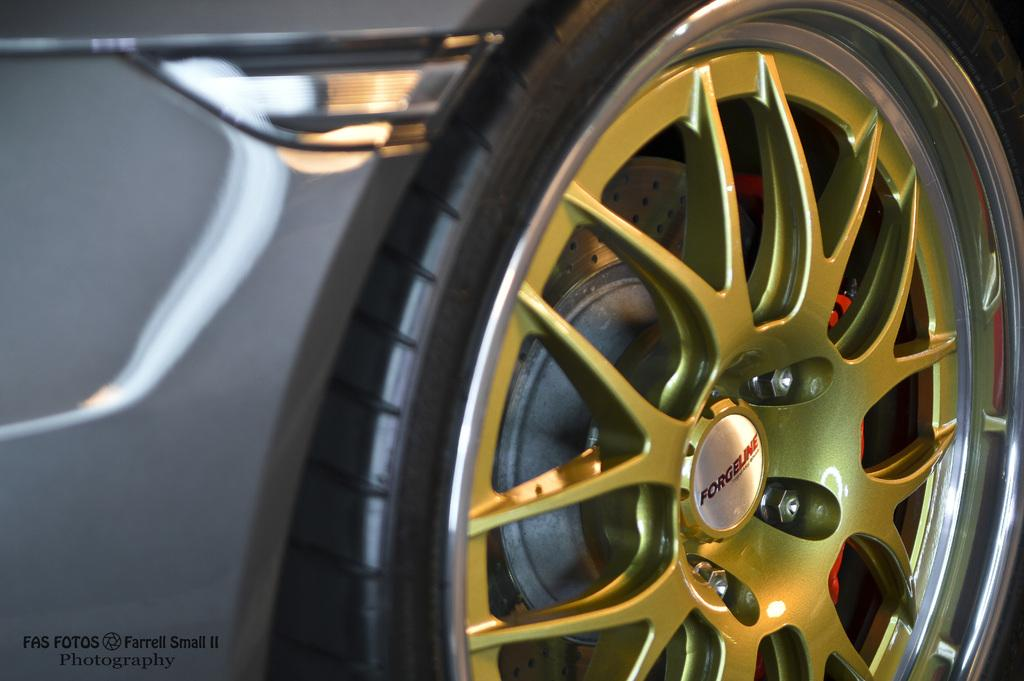What object related to a vehicle can be seen in the image? There is a tire of a vehicle in the image. Can you describe the tire in more detail? The tire appears to be round and made of rubber, as is typical for vehicle tires. What might the tire be used for? The tire is likely used for supporting the weight of a vehicle and providing traction on the road. Can you see an owl perched on the tire in the image? No, there is no owl present in the image. What does the tongue of the tire look like? Tires do not have tongues, as they are inanimate objects made of rubber and other materials. 